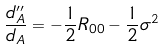Convert formula to latex. <formula><loc_0><loc_0><loc_500><loc_500>\frac { d _ { A } ^ { \prime \prime } } { d _ { A } } = - \frac { 1 } { 2 } R _ { 0 0 } - \frac { 1 } { 2 } \sigma ^ { 2 }</formula> 